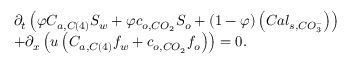<formula> <loc_0><loc_0><loc_500><loc_500>\begin{array} { r l } & { \partial _ { t } \left ( \varphi C _ { a , C \left ( 4 \right ) } S _ { w } + \varphi c _ { o , C O _ { 2 } } S _ { o } + \left ( 1 - \varphi \right ) \left ( C a l _ { s , C O _ { 3 } ^ { - } } \right ) \right ) } \\ & { + \partial _ { x } \left ( u \left ( C _ { a , C \left ( 4 \right ) } f _ { w } + c _ { o , C O _ { 2 } } f _ { o } \right ) \right ) = 0 . } \end{array}</formula> 